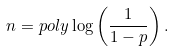Convert formula to latex. <formula><loc_0><loc_0><loc_500><loc_500>n = p o l y \log \left ( \frac { 1 } { 1 - p } \right ) .</formula> 